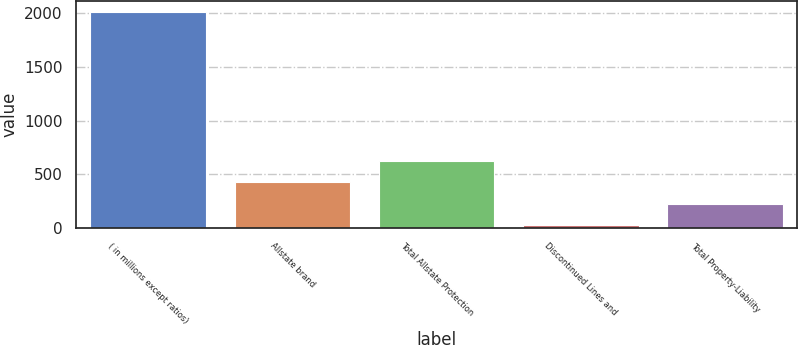<chart> <loc_0><loc_0><loc_500><loc_500><bar_chart><fcel>( in millions except ratios)<fcel>Allstate brand<fcel>Total Allstate Protection<fcel>Discontinued Lines and<fcel>Total Property-Liability<nl><fcel>2010<fcel>424.4<fcel>622.6<fcel>28<fcel>226.2<nl></chart> 